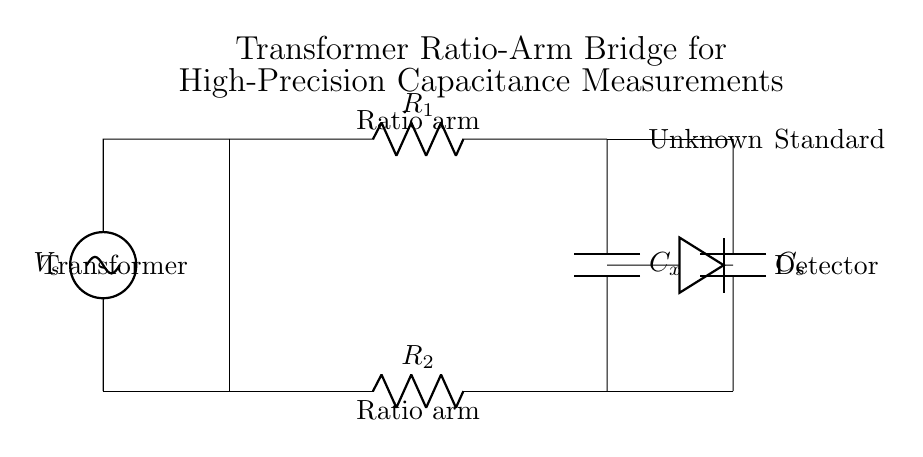What type of circuit is shown here? The circuit represents a transformer ratio-arm bridge, which is specifically designed for high-precision capacitance measurements. The presence of a transformer and the arrangement of resistors and capacitors indicate its functionality.
Answer: transformer ratio-arm bridge What does the 'C_x' component represent? 'C_x' refers to the unknown capacitor in the bridge circuit whose capacitance is being measured. This is deduced from its position in the circuit as one of the arms of the bridge.
Answer: unknown capacitor How many resistors are present in the circuit? There are two resistors shown in the circuit diagram. This can be confirmed by identifying the labeled elements 'R_1' and 'R_2' on the primary and secondary sides of the transformer.
Answer: two What is the role of the detector in this bridge circuit? The detector measures the difference in potential across the bridge, which indicates how well the bridge is balanced. When the ratio of capacitances is equal, there should be no voltage across the detector, providing a precise measurement of 'C_x'.
Answer: measures potential difference What is the purpose of using a transformer in this bridge circuit? The transformer is utilized to enhance measurement accuracy and allow for a high impedance at the input, which minimizes the loading effect on the capacitors being measured. Its primary side receives input voltage while providing necessary impedance transformation.
Answer: enhance measurement accuracy What is represented by 'C_s' in the circuit? 'C_s' stands for the standard capacitor, which is a fixed reference capacitor used to balance the bridge and compare against the unknown capacitor 'C_x'. It is essential for determining the value of 'C_x' through the comparative measurements.
Answer: standard capacitor What can be inferred about the balance of the bridge? When the bridge is balanced, it means the ratio of the capacitances and resistances in the bridge arms is equal, causing no current to flow through the detector. This situation allows for accurate determination of the unknown capacitance 'C_x'.
Answer: balanced condition 